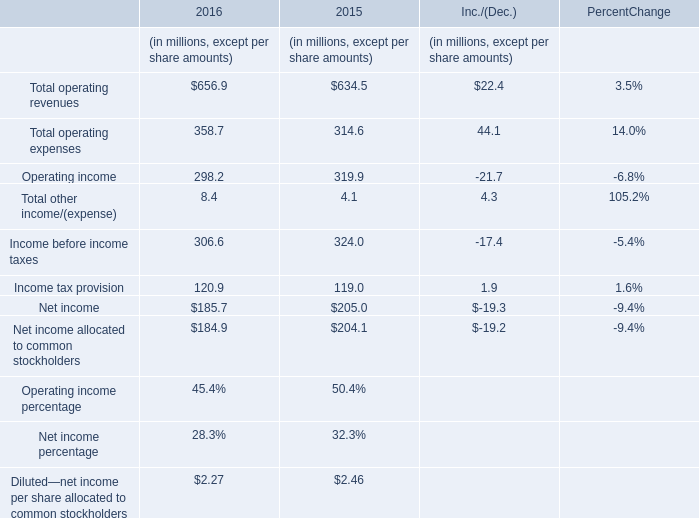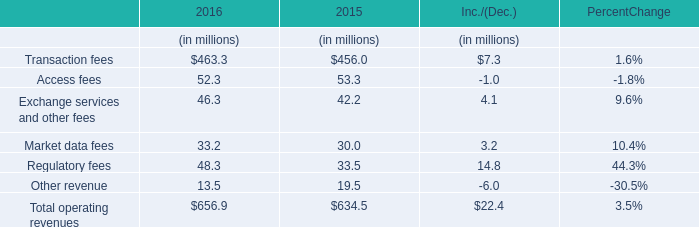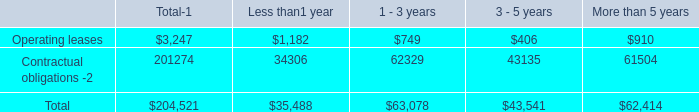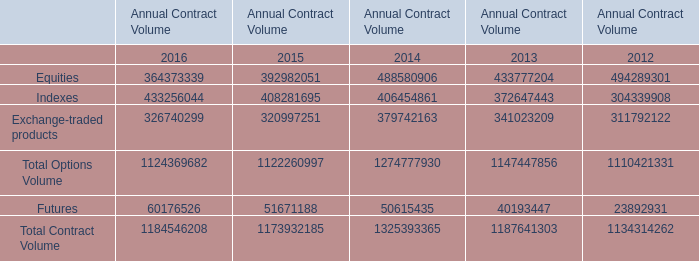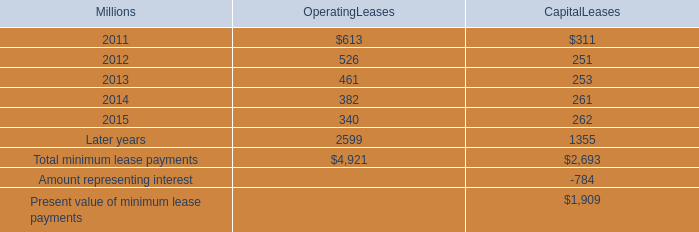in 2010 what was the percent of the early extinguishment charge to the amount of the outstanding 6.65% ( 6.65 % ) notes due january 15 , 2011 
Computations: (5 / 400)
Answer: 0.0125. 